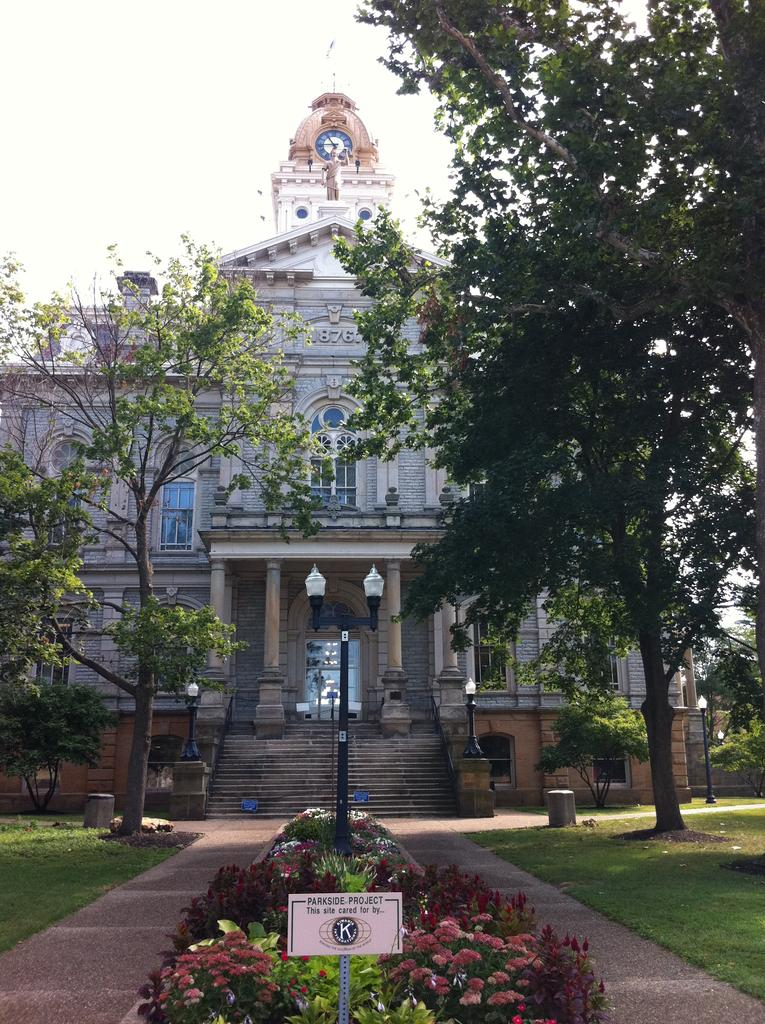<image>
Share a concise interpretation of the image provided. A building has a planted garden area in front of it with a plaque indicating it is a parkside project. 